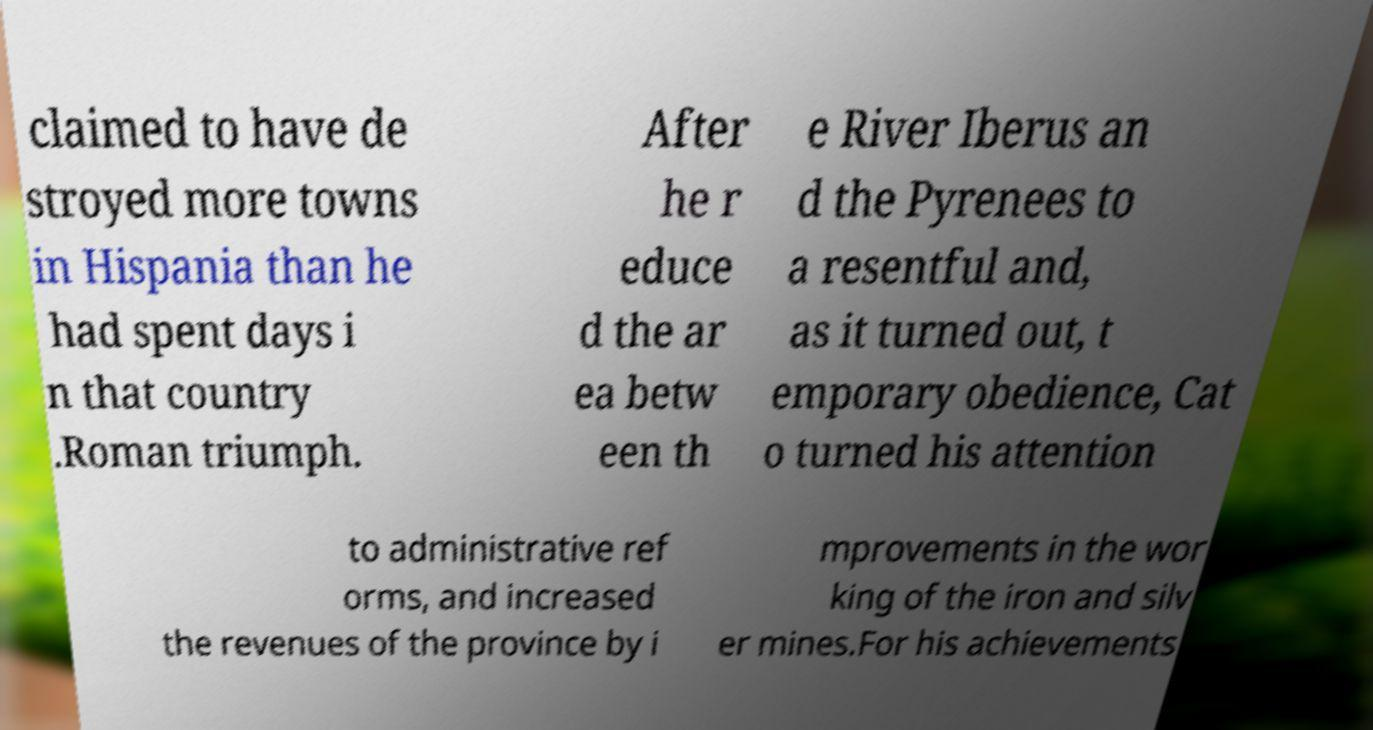What messages or text are displayed in this image? I need them in a readable, typed format. claimed to have de stroyed more towns in Hispania than he had spent days i n that country .Roman triumph. After he r educe d the ar ea betw een th e River Iberus an d the Pyrenees to a resentful and, as it turned out, t emporary obedience, Cat o turned his attention to administrative ref orms, and increased the revenues of the province by i mprovements in the wor king of the iron and silv er mines.For his achievements 